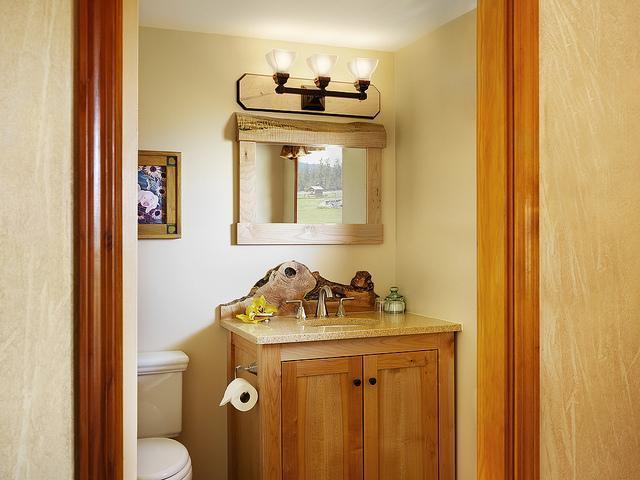How many green items are on sink counter?
Give a very brief answer. 1. 